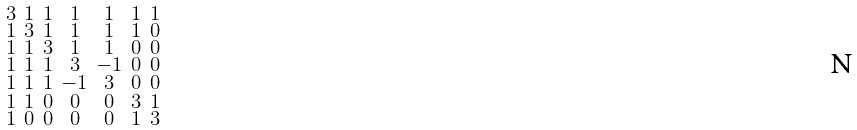Convert formula to latex. <formula><loc_0><loc_0><loc_500><loc_500>\begin{smallmatrix} 3 & 1 & 1 & 1 & 1 & 1 & 1 \\ 1 & 3 & 1 & 1 & 1 & 1 & 0 \\ 1 & 1 & 3 & 1 & 1 & 0 & 0 \\ 1 & 1 & 1 & 3 & - 1 & 0 & 0 \\ 1 & 1 & 1 & - 1 & 3 & 0 & 0 \\ 1 & 1 & 0 & 0 & 0 & 3 & 1 \\ 1 & 0 & 0 & 0 & 0 & 1 & 3 \end{smallmatrix}</formula> 